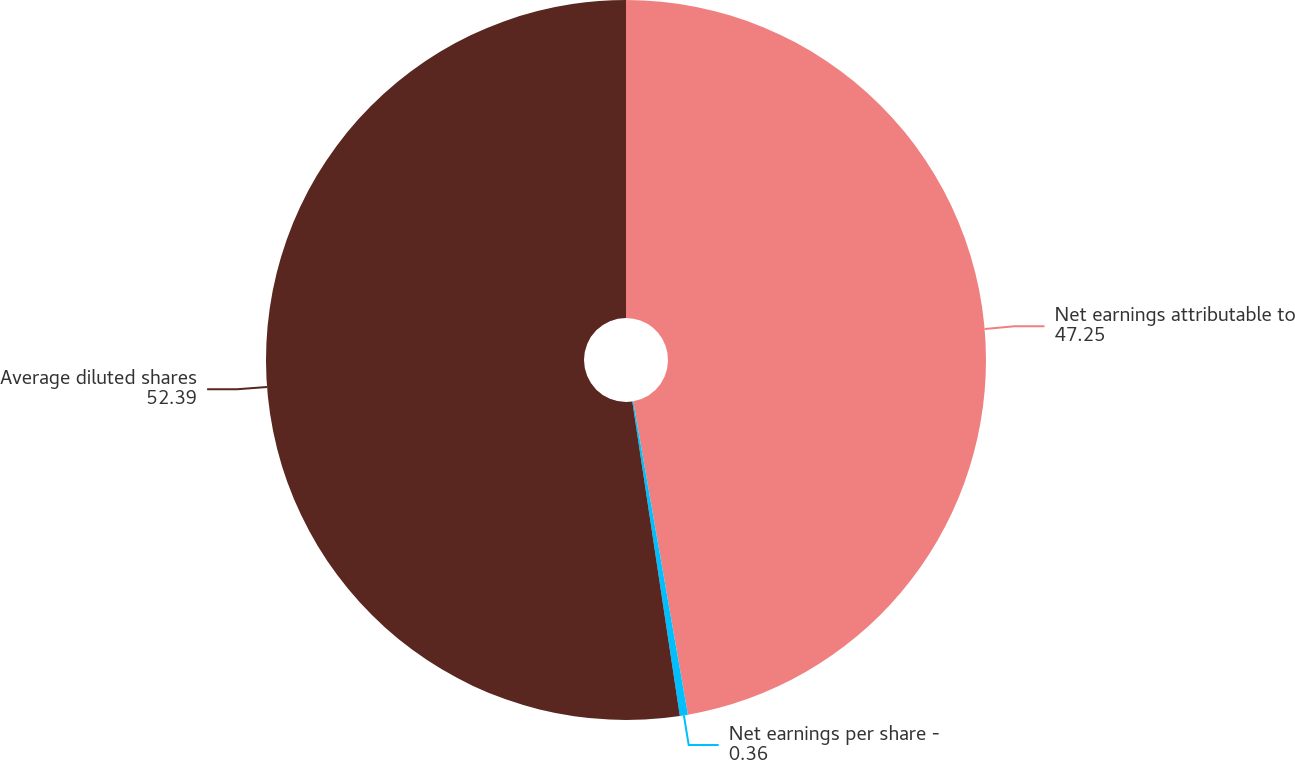Convert chart. <chart><loc_0><loc_0><loc_500><loc_500><pie_chart><fcel>Net earnings attributable to<fcel>Net earnings per share -<fcel>Average diluted shares<nl><fcel>47.25%<fcel>0.36%<fcel>52.39%<nl></chart> 